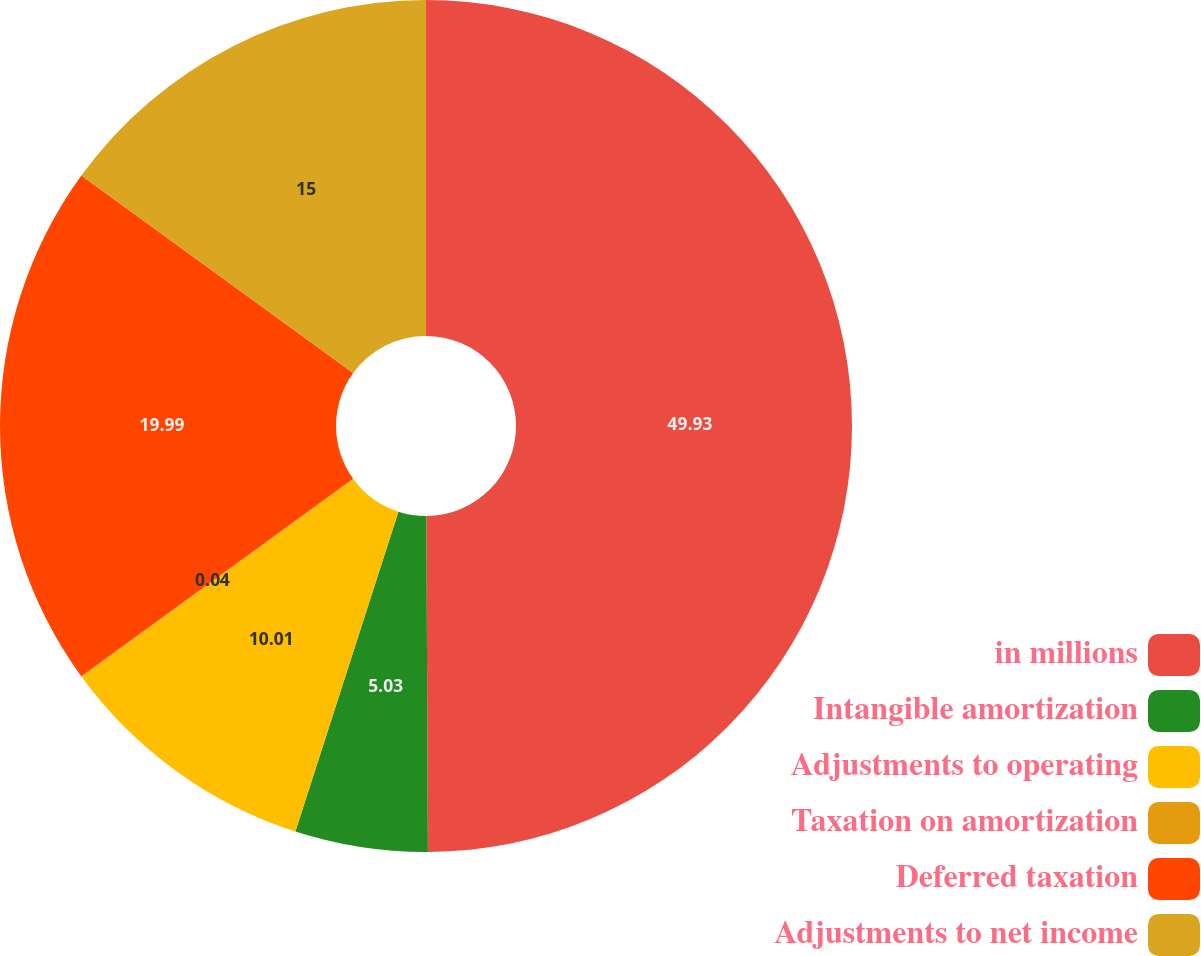<chart> <loc_0><loc_0><loc_500><loc_500><pie_chart><fcel>in millions<fcel>Intangible amortization<fcel>Adjustments to operating<fcel>Taxation on amortization<fcel>Deferred taxation<fcel>Adjustments to net income<nl><fcel>49.93%<fcel>5.03%<fcel>10.01%<fcel>0.04%<fcel>19.99%<fcel>15.0%<nl></chart> 